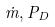<formula> <loc_0><loc_0><loc_500><loc_500>\dot { m } , P _ { D }</formula> 